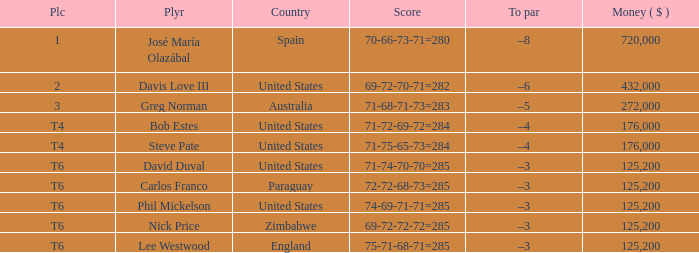Which Place has a To par of –8? 1.0. 